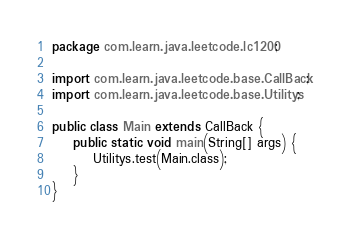Convert code to text. <code><loc_0><loc_0><loc_500><loc_500><_Java_>package com.learn.java.leetcode.lc1200;

import com.learn.java.leetcode.base.CallBack;
import com.learn.java.leetcode.base.Utilitys;

public class Main extends CallBack {
	public static void main(String[] args) {
		Utilitys.test(Main.class);
	}
}
</code> 